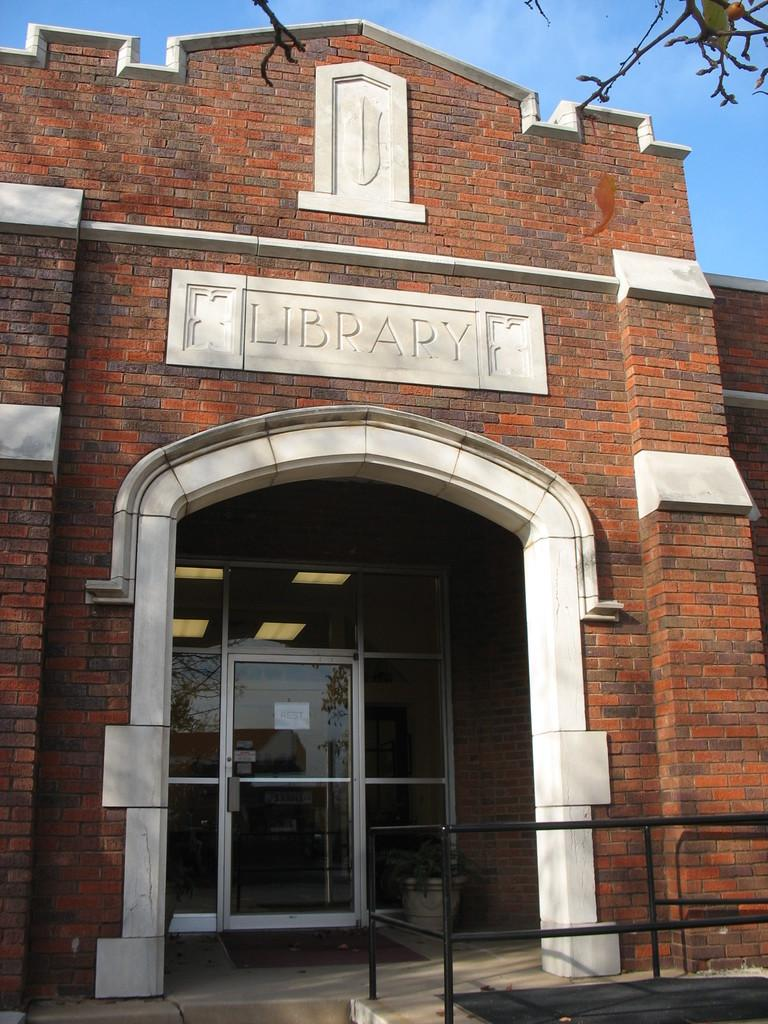<image>
Create a compact narrative representing the image presented. A brick building with Library engraved above its archway. 